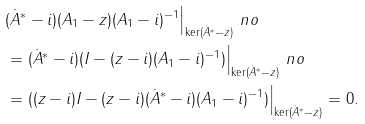Convert formula to latex. <formula><loc_0><loc_0><loc_500><loc_500>& ( \dot { A } ^ { * } - i ) ( A _ { 1 } - z ) ( A _ { 1 } - i ) ^ { - 1 } \Big | _ { \ker ( \dot { A } ^ { * } - z ) } \ n o \\ & = ( \dot { A } ^ { * } - i ) ( I - ( z - i ) ( A _ { 1 } - i ) ^ { - 1 } ) \Big | _ { \ker ( \dot { A } ^ { * } - z ) } \ n o \\ & = ( ( z - i ) I - ( z - i ) ( \dot { A } ^ { * } - i ) ( A _ { 1 } - i ) ^ { - 1 } ) \Big | _ { \ker ( \dot { A } ^ { * } - z ) } = 0 .</formula> 